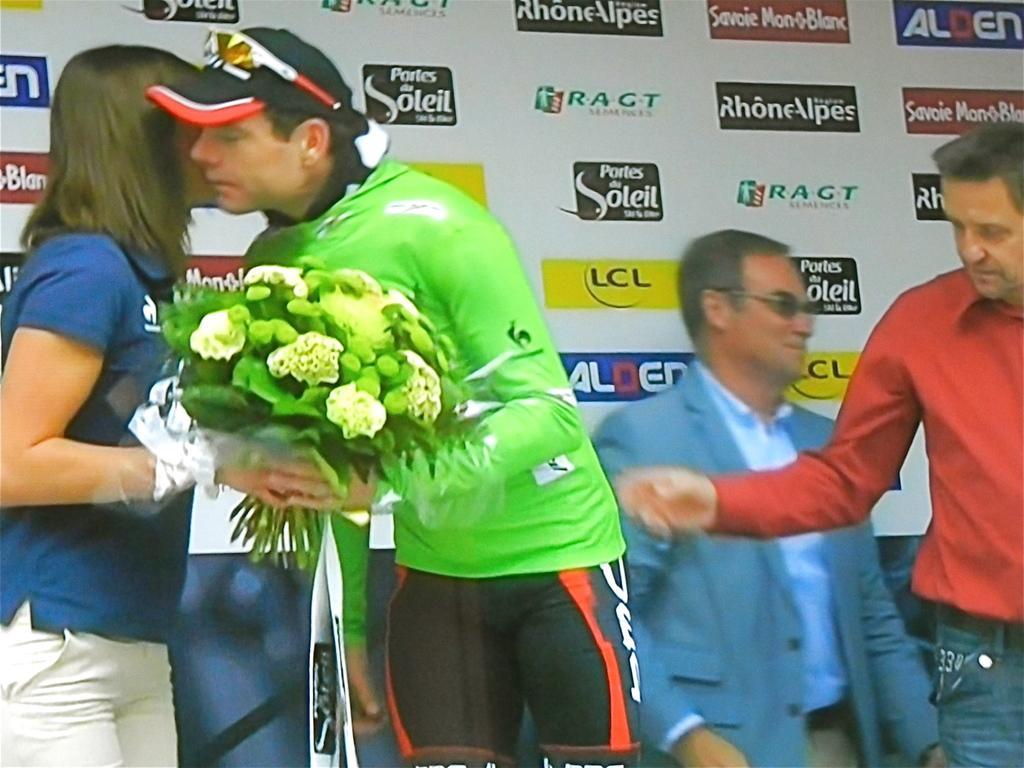In one or two sentences, can you explain what this image depicts? In this image I can see a person wearing green and black colored dress and a person wearing blue and white colored dress are standing and holding a flower bouquet which is green and cream in color. I can see few other persons standing and a huge banner which is white, black, yellow, blue and red in color. 